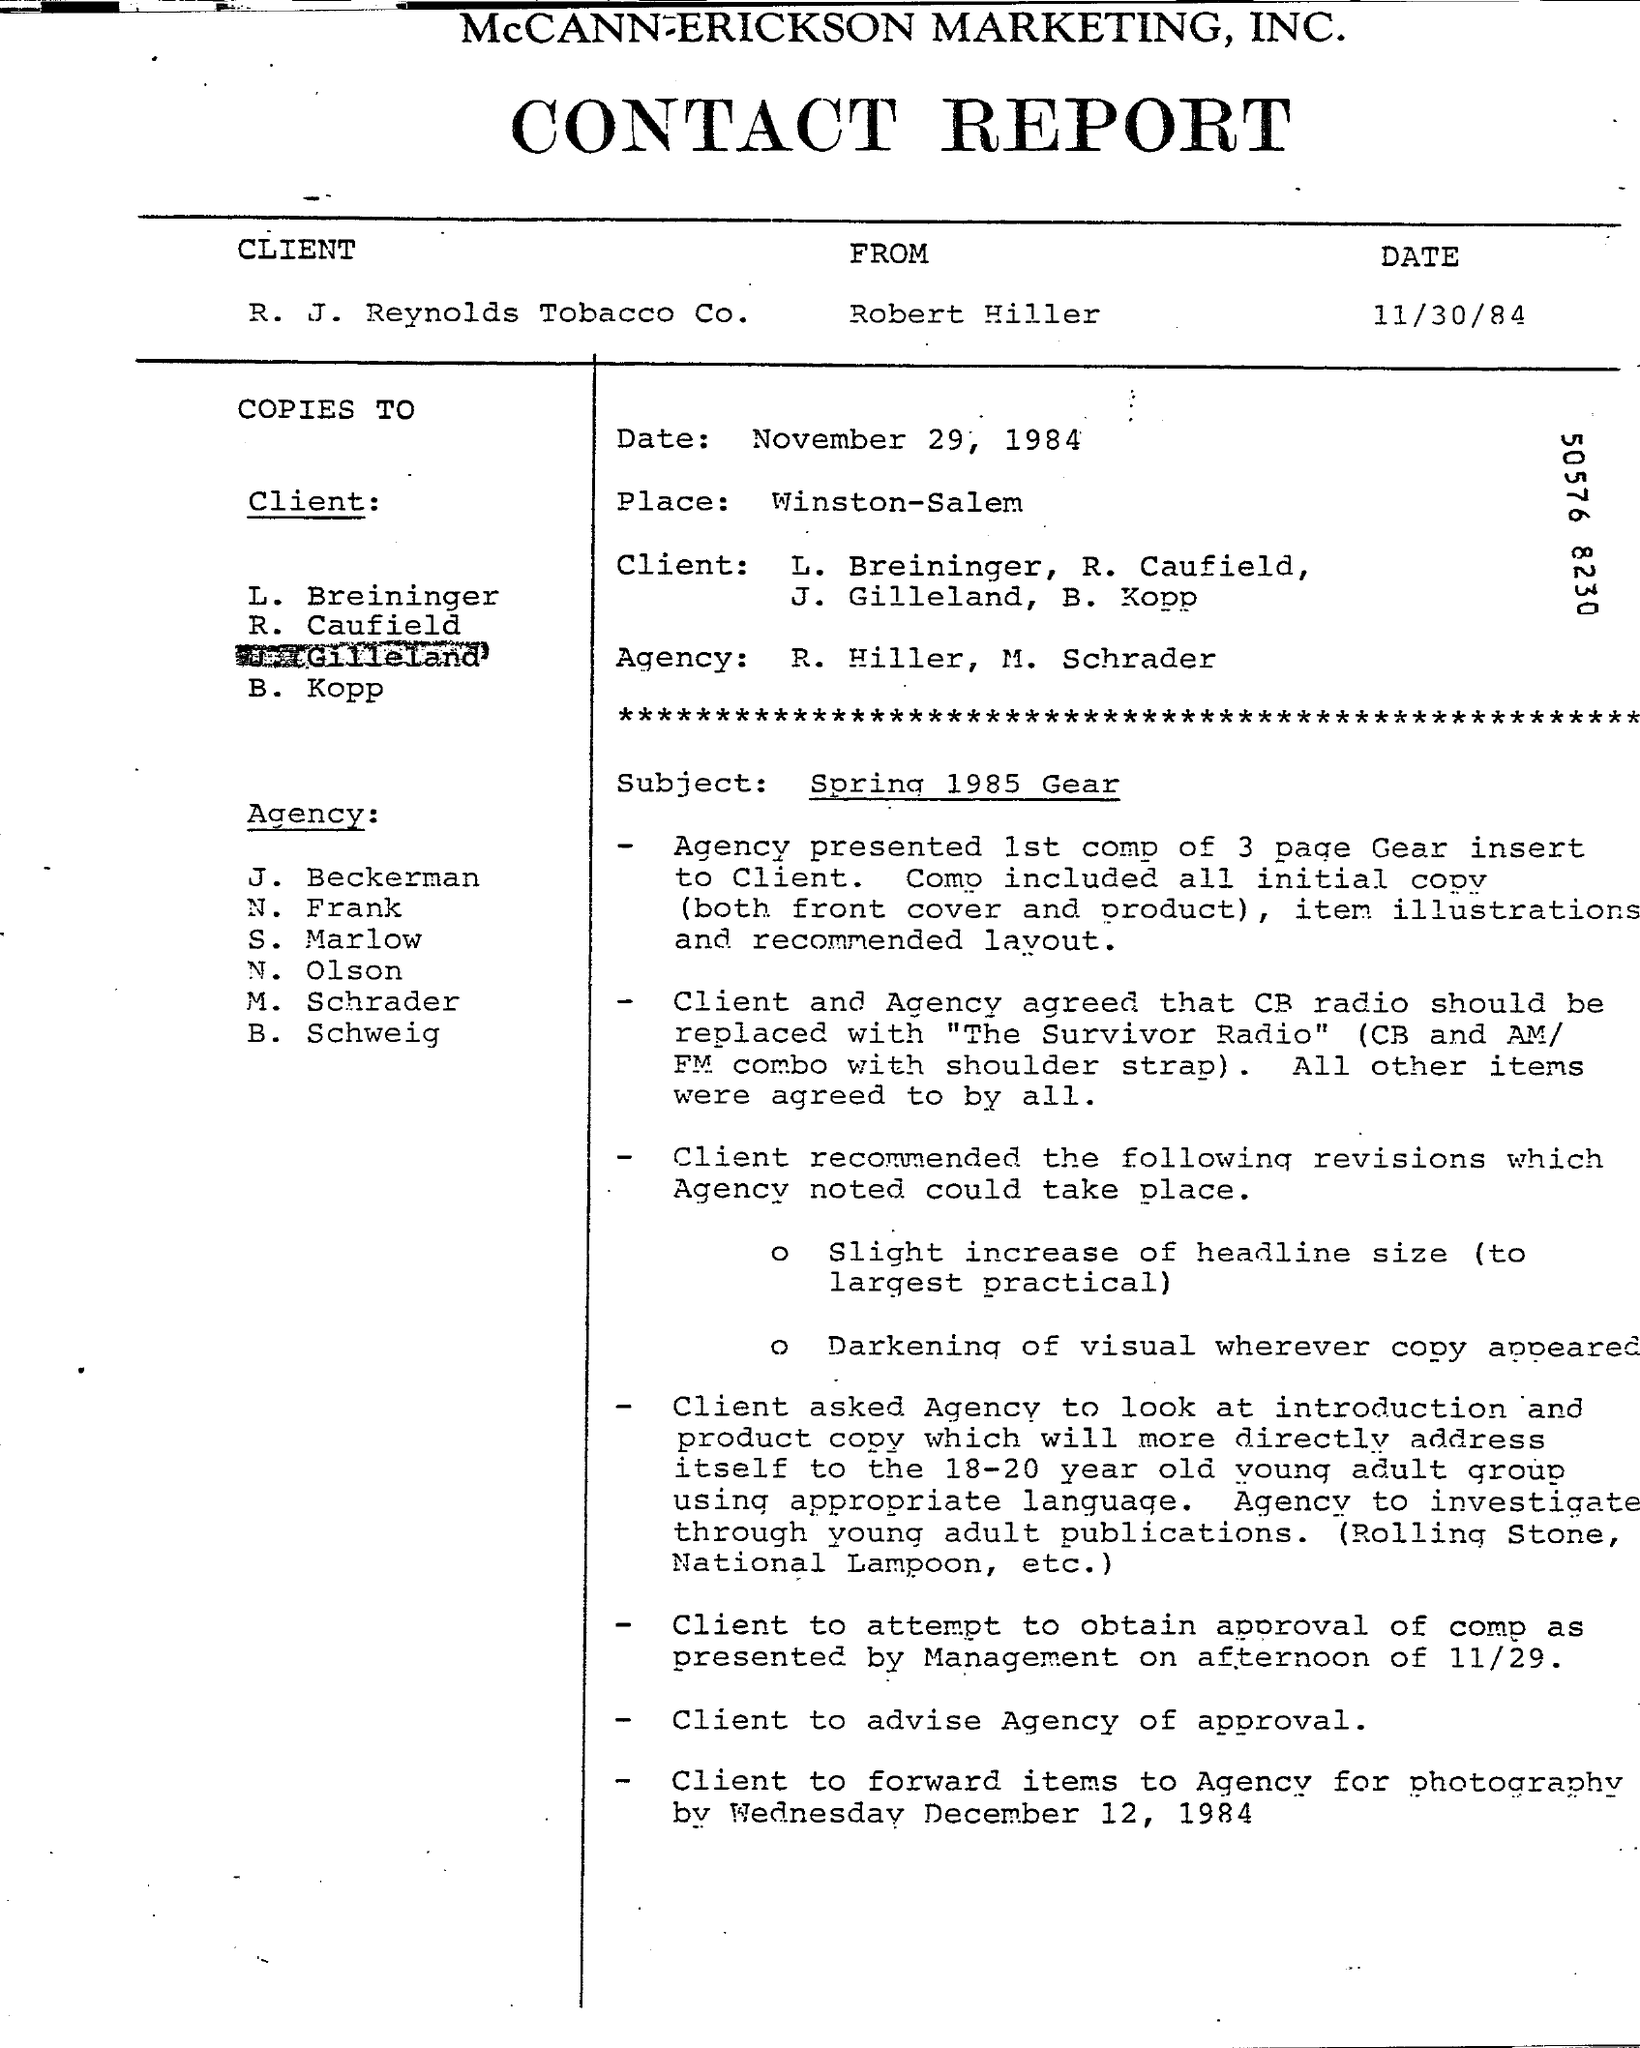Point out several critical features in this image. The author of the document is Robert Hiller. Winston-Salem is a place that has been mentioned. The heading of the document is "CONTACT REPORT. The date mentioned below the heading is "11/30/84. 